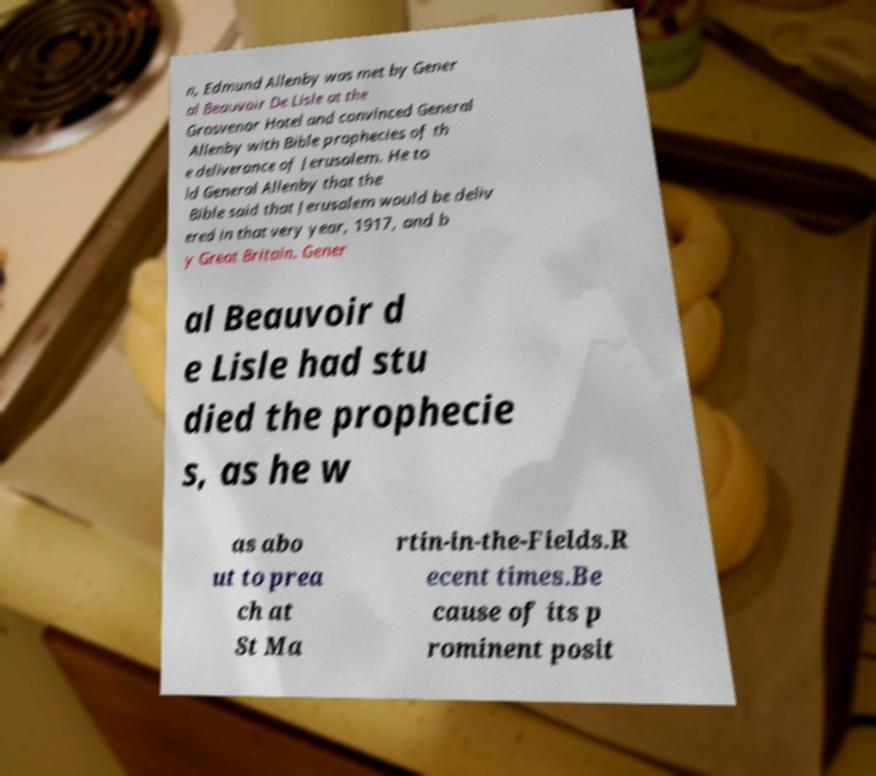For documentation purposes, I need the text within this image transcribed. Could you provide that? n, Edmund Allenby was met by Gener al Beauvoir De Lisle at the Grosvenor Hotel and convinced General Allenby with Bible prophecies of th e deliverance of Jerusalem. He to ld General Allenby that the Bible said that Jerusalem would be deliv ered in that very year, 1917, and b y Great Britain. Gener al Beauvoir d e Lisle had stu died the prophecie s, as he w as abo ut to prea ch at St Ma rtin-in-the-Fields.R ecent times.Be cause of its p rominent posit 